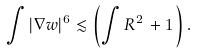Convert formula to latex. <formula><loc_0><loc_0><loc_500><loc_500>\int | \nabla w | ^ { 6 } \lesssim \left ( \int R ^ { 2 } \, + 1 \, \right ) .</formula> 